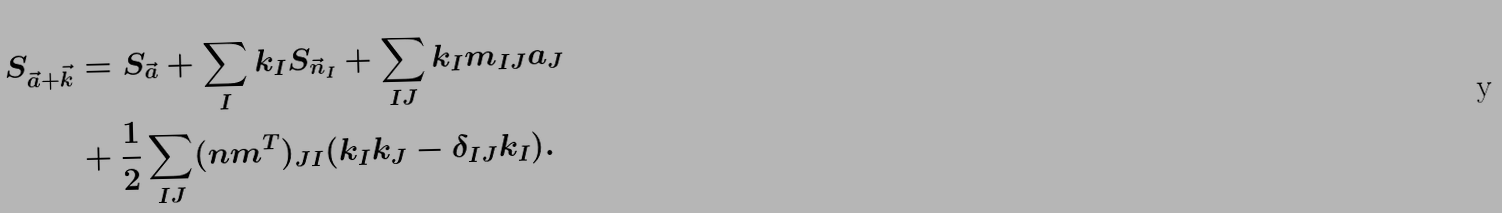Convert formula to latex. <formula><loc_0><loc_0><loc_500><loc_500>S _ { \vec { a } + \vec { k } } & = S _ { \vec { a } } + \sum _ { I } k _ { I } S _ { \vec { n } _ { I } } + \sum _ { I J } k _ { I } m _ { I J } a _ { J } \\ & + \frac { 1 } { 2 } \sum _ { I J } ( n m ^ { T } ) _ { J I } ( k _ { I } k _ { J } - \delta _ { I J } k _ { I } ) .</formula> 